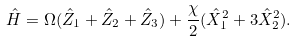<formula> <loc_0><loc_0><loc_500><loc_500>\hat { H } = \Omega ( \hat { Z } _ { 1 } + \hat { Z } _ { 2 } + \hat { Z } _ { 3 } ) + \frac { \chi } { 2 } ( \hat { X } _ { 1 } ^ { 2 } + 3 \hat { X } _ { 2 } ^ { 2 } ) .</formula> 